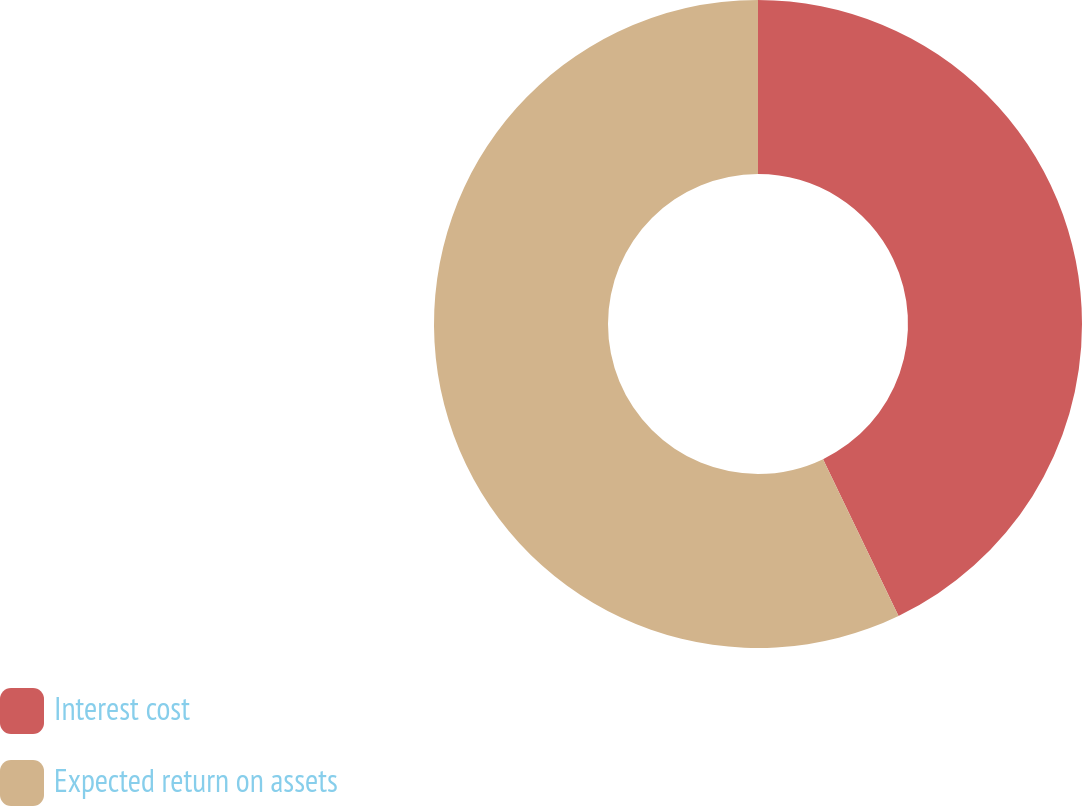Convert chart to OTSL. <chart><loc_0><loc_0><loc_500><loc_500><pie_chart><fcel>Interest cost<fcel>Expected return on assets<nl><fcel>42.86%<fcel>57.14%<nl></chart> 